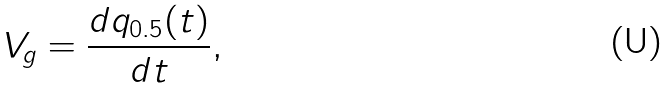Convert formula to latex. <formula><loc_0><loc_0><loc_500><loc_500>V _ { g } = \frac { d q _ { 0 . 5 } ( t ) } { d t } ,</formula> 